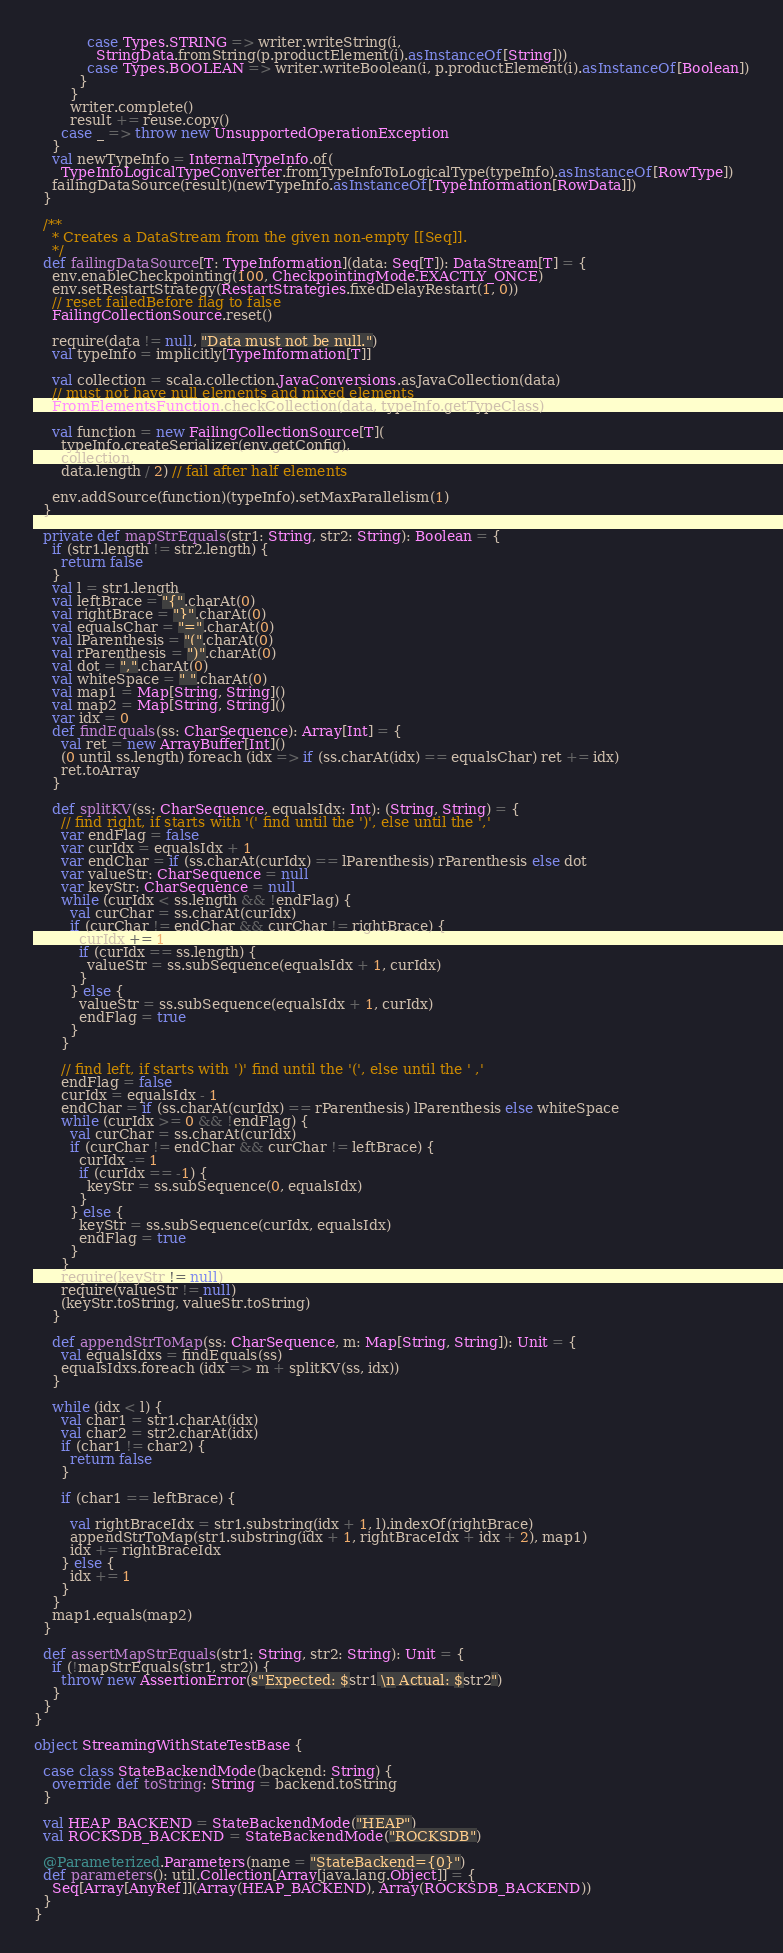Convert code to text. <code><loc_0><loc_0><loc_500><loc_500><_Scala_>            case Types.STRING => writer.writeString(i,
              StringData.fromString(p.productElement(i).asInstanceOf[String]))
            case Types.BOOLEAN => writer.writeBoolean(i, p.productElement(i).asInstanceOf[Boolean])
          }
        }
        writer.complete()
        result += reuse.copy()
      case _ => throw new UnsupportedOperationException
    }
    val newTypeInfo = InternalTypeInfo.of(
      TypeInfoLogicalTypeConverter.fromTypeInfoToLogicalType(typeInfo).asInstanceOf[RowType])
    failingDataSource(result)(newTypeInfo.asInstanceOf[TypeInformation[RowData]])
  }

  /**
    * Creates a DataStream from the given non-empty [[Seq]].
    */
  def failingDataSource[T: TypeInformation](data: Seq[T]): DataStream[T] = {
    env.enableCheckpointing(100, CheckpointingMode.EXACTLY_ONCE)
    env.setRestartStrategy(RestartStrategies.fixedDelayRestart(1, 0))
    // reset failedBefore flag to false
    FailingCollectionSource.reset()

    require(data != null, "Data must not be null.")
    val typeInfo = implicitly[TypeInformation[T]]

    val collection = scala.collection.JavaConversions.asJavaCollection(data)
    // must not have null elements and mixed elements
    FromElementsFunction.checkCollection(data, typeInfo.getTypeClass)

    val function = new FailingCollectionSource[T](
      typeInfo.createSerializer(env.getConfig),
      collection,
      data.length / 2) // fail after half elements

    env.addSource(function)(typeInfo).setMaxParallelism(1)
  }

  private def mapStrEquals(str1: String, str2: String): Boolean = {
    if (str1.length != str2.length) {
      return false
    }
    val l = str1.length
    val leftBrace = "{".charAt(0)
    val rightBrace = "}".charAt(0)
    val equalsChar = "=".charAt(0)
    val lParenthesis = "(".charAt(0)
    val rParenthesis = ")".charAt(0)
    val dot = ",".charAt(0)
    val whiteSpace = " ".charAt(0)
    val map1 = Map[String, String]()
    val map2 = Map[String, String]()
    var idx = 0
    def findEquals(ss: CharSequence): Array[Int] = {
      val ret = new ArrayBuffer[Int]()
      (0 until ss.length) foreach (idx => if (ss.charAt(idx) == equalsChar) ret += idx)
      ret.toArray
    }

    def splitKV(ss: CharSequence, equalsIdx: Int): (String, String) = {
      // find right, if starts with '(' find until the ')', else until the ','
      var endFlag = false
      var curIdx = equalsIdx + 1
      var endChar = if (ss.charAt(curIdx) == lParenthesis) rParenthesis else dot
      var valueStr: CharSequence = null
      var keyStr: CharSequence = null
      while (curIdx < ss.length && !endFlag) {
        val curChar = ss.charAt(curIdx)
        if (curChar != endChar && curChar != rightBrace) {
          curIdx += 1
          if (curIdx == ss.length) {
            valueStr = ss.subSequence(equalsIdx + 1, curIdx)
          }
        } else {
          valueStr = ss.subSequence(equalsIdx + 1, curIdx)
          endFlag = true
        }
      }

      // find left, if starts with ')' find until the '(', else until the ' ,'
      endFlag = false
      curIdx = equalsIdx - 1
      endChar = if (ss.charAt(curIdx) == rParenthesis) lParenthesis else whiteSpace
      while (curIdx >= 0 && !endFlag) {
        val curChar = ss.charAt(curIdx)
        if (curChar != endChar && curChar != leftBrace) {
          curIdx -= 1
          if (curIdx == -1) {
            keyStr = ss.subSequence(0, equalsIdx)
          }
        } else {
          keyStr = ss.subSequence(curIdx, equalsIdx)
          endFlag = true
        }
      }
      require(keyStr != null)
      require(valueStr != null)
      (keyStr.toString, valueStr.toString)
    }

    def appendStrToMap(ss: CharSequence, m: Map[String, String]): Unit = {
      val equalsIdxs = findEquals(ss)
      equalsIdxs.foreach (idx => m + splitKV(ss, idx))
    }

    while (idx < l) {
      val char1 = str1.charAt(idx)
      val char2 = str2.charAt(idx)
      if (char1 != char2) {
        return false
      }

      if (char1 == leftBrace) {

        val rightBraceIdx = str1.substring(idx + 1, l).indexOf(rightBrace)
        appendStrToMap(str1.substring(idx + 1, rightBraceIdx + idx + 2), map1)
        idx += rightBraceIdx
      } else {
        idx += 1
      }
    }
    map1.equals(map2)
  }

  def assertMapStrEquals(str1: String, str2: String): Unit = {
    if (!mapStrEquals(str1, str2)) {
      throw new AssertionError(s"Expected: $str1 \n Actual: $str2")
    }
  }
}

object StreamingWithStateTestBase {

  case class StateBackendMode(backend: String) {
    override def toString: String = backend.toString
  }

  val HEAP_BACKEND = StateBackendMode("HEAP")
  val ROCKSDB_BACKEND = StateBackendMode("ROCKSDB")

  @Parameterized.Parameters(name = "StateBackend={0}")
  def parameters(): util.Collection[Array[java.lang.Object]] = {
    Seq[Array[AnyRef]](Array(HEAP_BACKEND), Array(ROCKSDB_BACKEND))
  }
}
</code> 